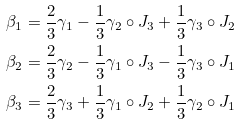<formula> <loc_0><loc_0><loc_500><loc_500>\beta _ { 1 } & = \frac { 2 } { 3 } \gamma _ { 1 } - \frac { 1 } { 3 } \gamma _ { 2 } \circ J _ { 3 } + \frac { 1 } { 3 } \gamma _ { 3 } \circ J _ { 2 } \\ \beta _ { 2 } & = \frac { 2 } { 3 } \gamma _ { 2 } - \frac { 1 } { 3 } \gamma _ { 1 } \circ J _ { 3 } - \frac { 1 } { 3 } \gamma _ { 3 } \circ J _ { 1 } \\ \beta _ { 3 } & = \frac { 2 } { 3 } \gamma _ { 3 } + \frac { 1 } { 3 } \gamma _ { 1 } \circ J _ { 2 } + \frac { 1 } { 3 } \gamma _ { 2 } \circ J _ { 1 }</formula> 